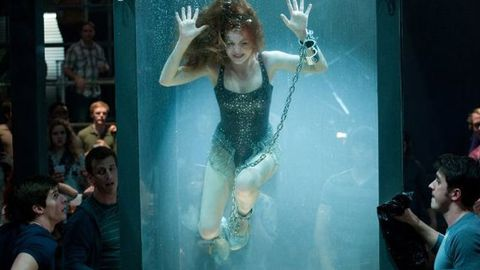How might someone prepare for an act like this? For an underwater escape act, the person would undergo rigorous physical training to increase breath-holding capacity, as well as practice lock-picking and escapology techniques. Mental preparation to remain calm under stress would also be essential. Safety measures would be in place during the act to ensure the performer's well-being. What do you think the audience is feeling? The audience is likely experiencing a mix of excitement, suspense, and concern. Escape acts are designed to draw spectators into the drama of the moment, keeping them on the edge of their seats as they witness the performer's struggle against the literal constraints before them. 